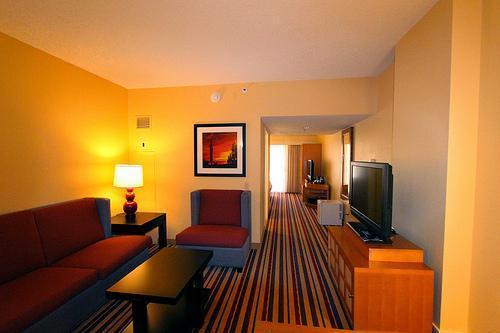How many sofas are there?
Give a very brief answer. 1. 